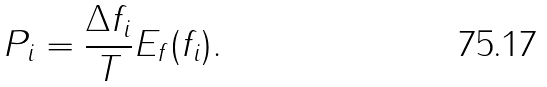Convert formula to latex. <formula><loc_0><loc_0><loc_500><loc_500>P _ { i } = \frac { \Delta f _ { i } } { T } E _ { f } ( f _ { i } ) .</formula> 